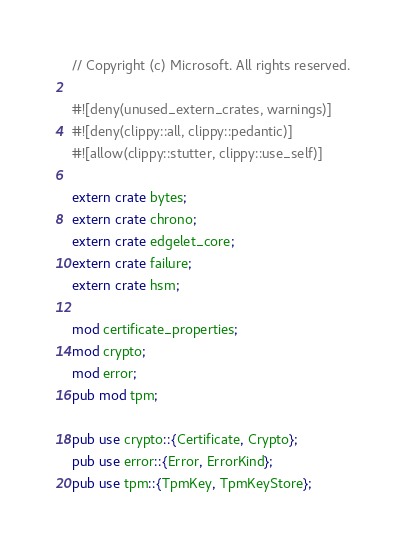Convert code to text. <code><loc_0><loc_0><loc_500><loc_500><_Rust_>// Copyright (c) Microsoft. All rights reserved.

#![deny(unused_extern_crates, warnings)]
#![deny(clippy::all, clippy::pedantic)]
#![allow(clippy::stutter, clippy::use_self)]

extern crate bytes;
extern crate chrono;
extern crate edgelet_core;
extern crate failure;
extern crate hsm;

mod certificate_properties;
mod crypto;
mod error;
pub mod tpm;

pub use crypto::{Certificate, Crypto};
pub use error::{Error, ErrorKind};
pub use tpm::{TpmKey, TpmKeyStore};
</code> 